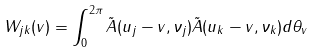Convert formula to latex. <formula><loc_0><loc_0><loc_500><loc_500>W _ { j k } ( v ) = \int _ { 0 } ^ { 2 \pi } \tilde { A } ( { u } _ { j } - { v } , \nu _ { j } ) \tilde { A } ( { u } _ { k } - { v } , \nu _ { k } ) d \theta _ { v }</formula> 